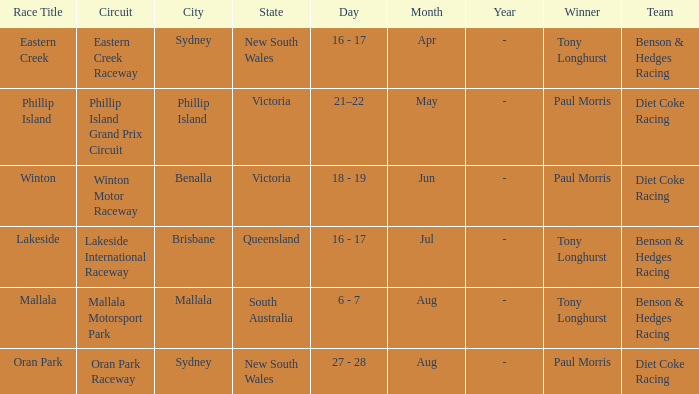When was the Mallala race held? 6 - 7 Aug. 